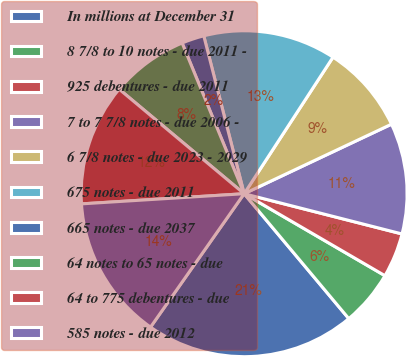Convert chart. <chart><loc_0><loc_0><loc_500><loc_500><pie_chart><fcel>In millions at December 31<fcel>8 7/8 to 10 notes - due 2011 -<fcel>925 debentures - due 2011<fcel>7 to 7 7/8 notes - due 2006 -<fcel>6 7/8 notes - due 2023 - 2029<fcel>675 notes - due 2011<fcel>665 notes - due 2037<fcel>64 notes to 65 notes - due<fcel>64 to 775 debentures - due<fcel>585 notes - due 2012<nl><fcel>20.84%<fcel>5.51%<fcel>4.42%<fcel>10.99%<fcel>8.8%<fcel>13.17%<fcel>2.23%<fcel>7.7%<fcel>12.08%<fcel>14.27%<nl></chart> 